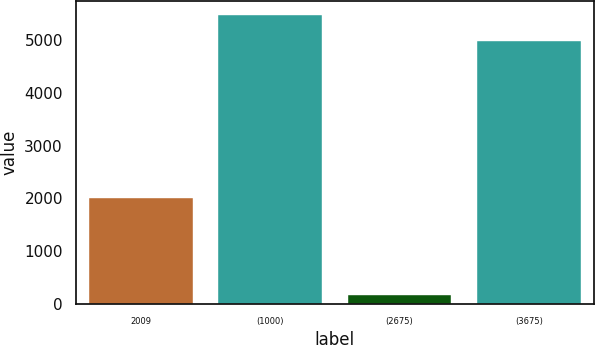<chart> <loc_0><loc_0><loc_500><loc_500><bar_chart><fcel>2009<fcel>(1000)<fcel>(2675)<fcel>(3675)<nl><fcel>2007<fcel>5475.8<fcel>158<fcel>4978<nl></chart> 